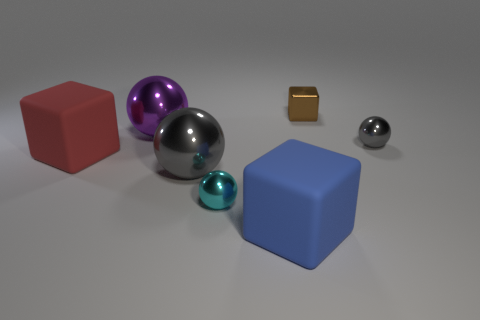Subtract all purple spheres. How many spheres are left? 3 Add 3 big matte things. How many objects exist? 10 Subtract all red balls. Subtract all gray blocks. How many balls are left? 4 Subtract all tiny yellow matte blocks. Subtract all tiny gray balls. How many objects are left? 6 Add 4 large objects. How many large objects are left? 8 Add 6 cyan matte cubes. How many cyan matte cubes exist? 6 Subtract 1 blue cubes. How many objects are left? 6 Subtract all blocks. How many objects are left? 4 